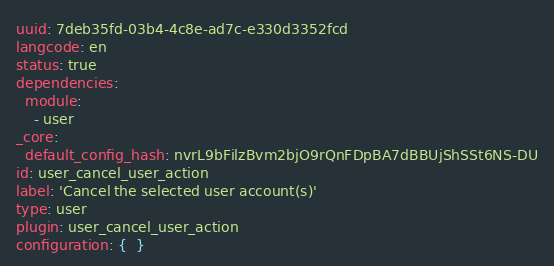<code> <loc_0><loc_0><loc_500><loc_500><_YAML_>uuid: 7deb35fd-03b4-4c8e-ad7c-e330d3352fcd
langcode: en
status: true
dependencies:
  module:
    - user
_core:
  default_config_hash: nvrL9bFilzBvm2bjO9rQnFDpBA7dBBUjShSSt6NS-DU
id: user_cancel_user_action
label: 'Cancel the selected user account(s)'
type: user
plugin: user_cancel_user_action
configuration: {  }
</code> 